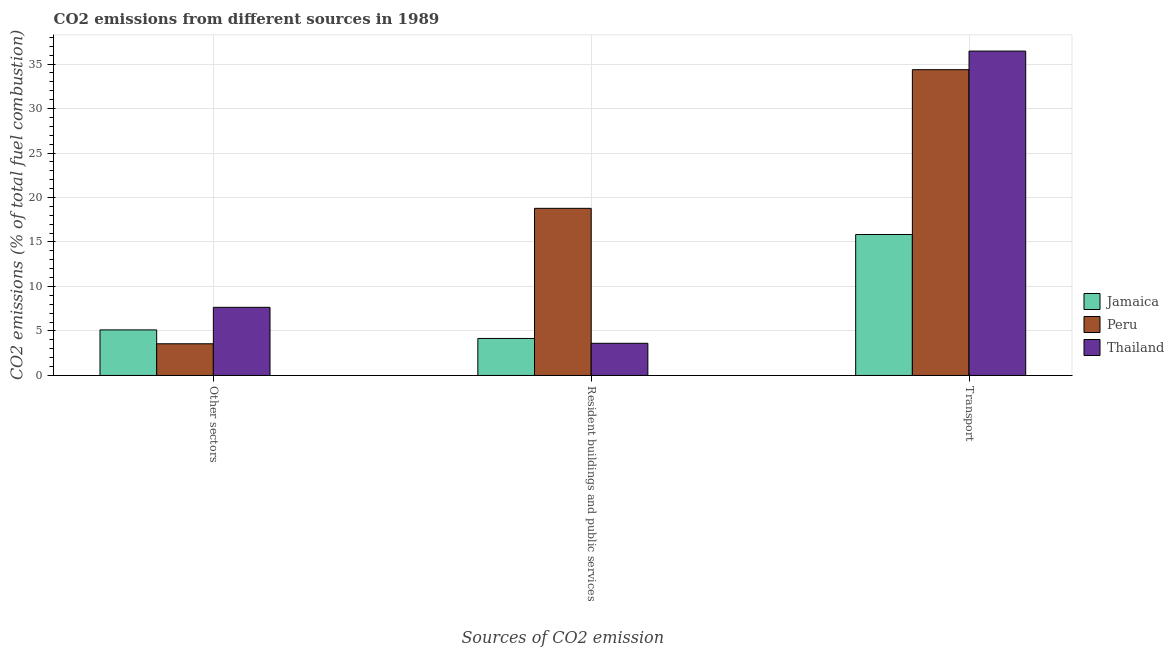How many different coloured bars are there?
Your answer should be compact. 3. How many groups of bars are there?
Offer a very short reply. 3. Are the number of bars per tick equal to the number of legend labels?
Offer a very short reply. Yes. How many bars are there on the 3rd tick from the left?
Make the answer very short. 3. What is the label of the 3rd group of bars from the left?
Keep it short and to the point. Transport. What is the percentage of co2 emissions from other sectors in Jamaica?
Your answer should be compact. 5.12. Across all countries, what is the maximum percentage of co2 emissions from resident buildings and public services?
Your answer should be compact. 18.78. Across all countries, what is the minimum percentage of co2 emissions from other sectors?
Your answer should be very brief. 3.56. In which country was the percentage of co2 emissions from transport maximum?
Your response must be concise. Thailand. In which country was the percentage of co2 emissions from resident buildings and public services minimum?
Your answer should be very brief. Thailand. What is the total percentage of co2 emissions from other sectors in the graph?
Offer a terse response. 16.34. What is the difference between the percentage of co2 emissions from resident buildings and public services in Jamaica and that in Peru?
Offer a very short reply. -14.62. What is the difference between the percentage of co2 emissions from resident buildings and public services in Thailand and the percentage of co2 emissions from other sectors in Peru?
Give a very brief answer. 0.06. What is the average percentage of co2 emissions from resident buildings and public services per country?
Make the answer very short. 8.85. What is the difference between the percentage of co2 emissions from resident buildings and public services and percentage of co2 emissions from transport in Thailand?
Keep it short and to the point. -32.84. In how many countries, is the percentage of co2 emissions from resident buildings and public services greater than 3 %?
Offer a terse response. 3. What is the ratio of the percentage of co2 emissions from transport in Thailand to that in Jamaica?
Offer a terse response. 2.3. Is the percentage of co2 emissions from transport in Peru less than that in Jamaica?
Your response must be concise. No. What is the difference between the highest and the second highest percentage of co2 emissions from transport?
Offer a very short reply. 2.09. What is the difference between the highest and the lowest percentage of co2 emissions from other sectors?
Your answer should be compact. 4.1. What does the 3rd bar from the left in Other sectors represents?
Ensure brevity in your answer.  Thailand. What does the 2nd bar from the right in Resident buildings and public services represents?
Provide a succinct answer. Peru. How many bars are there?
Give a very brief answer. 9. Are all the bars in the graph horizontal?
Make the answer very short. No. What is the difference between two consecutive major ticks on the Y-axis?
Your answer should be very brief. 5. Does the graph contain grids?
Your answer should be compact. Yes. Where does the legend appear in the graph?
Make the answer very short. Center right. How many legend labels are there?
Your answer should be very brief. 3. How are the legend labels stacked?
Your answer should be very brief. Vertical. What is the title of the graph?
Offer a very short reply. CO2 emissions from different sources in 1989. Does "Romania" appear as one of the legend labels in the graph?
Your answer should be very brief. No. What is the label or title of the X-axis?
Keep it short and to the point. Sources of CO2 emission. What is the label or title of the Y-axis?
Your answer should be compact. CO2 emissions (% of total fuel combustion). What is the CO2 emissions (% of total fuel combustion) in Jamaica in Other sectors?
Give a very brief answer. 5.12. What is the CO2 emissions (% of total fuel combustion) in Peru in Other sectors?
Offer a terse response. 3.56. What is the CO2 emissions (% of total fuel combustion) of Thailand in Other sectors?
Provide a short and direct response. 7.66. What is the CO2 emissions (% of total fuel combustion) of Jamaica in Resident buildings and public services?
Keep it short and to the point. 4.16. What is the CO2 emissions (% of total fuel combustion) of Peru in Resident buildings and public services?
Provide a short and direct response. 18.78. What is the CO2 emissions (% of total fuel combustion) in Thailand in Resident buildings and public services?
Offer a very short reply. 3.62. What is the CO2 emissions (% of total fuel combustion) of Jamaica in Transport?
Make the answer very short. 15.84. What is the CO2 emissions (% of total fuel combustion) of Peru in Transport?
Give a very brief answer. 34.37. What is the CO2 emissions (% of total fuel combustion) of Thailand in Transport?
Provide a succinct answer. 36.45. Across all Sources of CO2 emission, what is the maximum CO2 emissions (% of total fuel combustion) in Jamaica?
Your answer should be very brief. 15.84. Across all Sources of CO2 emission, what is the maximum CO2 emissions (% of total fuel combustion) in Peru?
Offer a very short reply. 34.37. Across all Sources of CO2 emission, what is the maximum CO2 emissions (% of total fuel combustion) of Thailand?
Your response must be concise. 36.45. Across all Sources of CO2 emission, what is the minimum CO2 emissions (% of total fuel combustion) of Jamaica?
Offer a very short reply. 4.16. Across all Sources of CO2 emission, what is the minimum CO2 emissions (% of total fuel combustion) in Peru?
Make the answer very short. 3.56. Across all Sources of CO2 emission, what is the minimum CO2 emissions (% of total fuel combustion) of Thailand?
Keep it short and to the point. 3.62. What is the total CO2 emissions (% of total fuel combustion) in Jamaica in the graph?
Offer a very short reply. 25.12. What is the total CO2 emissions (% of total fuel combustion) in Peru in the graph?
Ensure brevity in your answer.  56.71. What is the total CO2 emissions (% of total fuel combustion) of Thailand in the graph?
Your answer should be very brief. 47.73. What is the difference between the CO2 emissions (% of total fuel combustion) of Peru in Other sectors and that in Resident buildings and public services?
Your answer should be compact. -15.22. What is the difference between the CO2 emissions (% of total fuel combustion) in Thailand in Other sectors and that in Resident buildings and public services?
Make the answer very short. 4.04. What is the difference between the CO2 emissions (% of total fuel combustion) in Jamaica in Other sectors and that in Transport?
Make the answer very short. -10.72. What is the difference between the CO2 emissions (% of total fuel combustion) in Peru in Other sectors and that in Transport?
Keep it short and to the point. -30.8. What is the difference between the CO2 emissions (% of total fuel combustion) in Thailand in Other sectors and that in Transport?
Make the answer very short. -28.8. What is the difference between the CO2 emissions (% of total fuel combustion) of Jamaica in Resident buildings and public services and that in Transport?
Make the answer very short. -11.68. What is the difference between the CO2 emissions (% of total fuel combustion) in Peru in Resident buildings and public services and that in Transport?
Provide a succinct answer. -15.58. What is the difference between the CO2 emissions (% of total fuel combustion) of Thailand in Resident buildings and public services and that in Transport?
Give a very brief answer. -32.84. What is the difference between the CO2 emissions (% of total fuel combustion) in Jamaica in Other sectors and the CO2 emissions (% of total fuel combustion) in Peru in Resident buildings and public services?
Provide a succinct answer. -13.66. What is the difference between the CO2 emissions (% of total fuel combustion) of Jamaica in Other sectors and the CO2 emissions (% of total fuel combustion) of Thailand in Resident buildings and public services?
Give a very brief answer. 1.5. What is the difference between the CO2 emissions (% of total fuel combustion) of Peru in Other sectors and the CO2 emissions (% of total fuel combustion) of Thailand in Resident buildings and public services?
Keep it short and to the point. -0.06. What is the difference between the CO2 emissions (% of total fuel combustion) in Jamaica in Other sectors and the CO2 emissions (% of total fuel combustion) in Peru in Transport?
Give a very brief answer. -29.25. What is the difference between the CO2 emissions (% of total fuel combustion) of Jamaica in Other sectors and the CO2 emissions (% of total fuel combustion) of Thailand in Transport?
Keep it short and to the point. -31.33. What is the difference between the CO2 emissions (% of total fuel combustion) of Peru in Other sectors and the CO2 emissions (% of total fuel combustion) of Thailand in Transport?
Provide a short and direct response. -32.89. What is the difference between the CO2 emissions (% of total fuel combustion) of Jamaica in Resident buildings and public services and the CO2 emissions (% of total fuel combustion) of Peru in Transport?
Your answer should be compact. -30.21. What is the difference between the CO2 emissions (% of total fuel combustion) in Jamaica in Resident buildings and public services and the CO2 emissions (% of total fuel combustion) in Thailand in Transport?
Your response must be concise. -32.29. What is the difference between the CO2 emissions (% of total fuel combustion) of Peru in Resident buildings and public services and the CO2 emissions (% of total fuel combustion) of Thailand in Transport?
Your answer should be compact. -17.67. What is the average CO2 emissions (% of total fuel combustion) in Jamaica per Sources of CO2 emission?
Your response must be concise. 8.37. What is the average CO2 emissions (% of total fuel combustion) in Peru per Sources of CO2 emission?
Give a very brief answer. 18.9. What is the average CO2 emissions (% of total fuel combustion) of Thailand per Sources of CO2 emission?
Make the answer very short. 15.91. What is the difference between the CO2 emissions (% of total fuel combustion) of Jamaica and CO2 emissions (% of total fuel combustion) of Peru in Other sectors?
Provide a short and direct response. 1.56. What is the difference between the CO2 emissions (% of total fuel combustion) in Jamaica and CO2 emissions (% of total fuel combustion) in Thailand in Other sectors?
Your answer should be compact. -2.54. What is the difference between the CO2 emissions (% of total fuel combustion) of Peru and CO2 emissions (% of total fuel combustion) of Thailand in Other sectors?
Offer a terse response. -4.1. What is the difference between the CO2 emissions (% of total fuel combustion) in Jamaica and CO2 emissions (% of total fuel combustion) in Peru in Resident buildings and public services?
Provide a short and direct response. -14.62. What is the difference between the CO2 emissions (% of total fuel combustion) in Jamaica and CO2 emissions (% of total fuel combustion) in Thailand in Resident buildings and public services?
Make the answer very short. 0.54. What is the difference between the CO2 emissions (% of total fuel combustion) in Peru and CO2 emissions (% of total fuel combustion) in Thailand in Resident buildings and public services?
Your response must be concise. 15.17. What is the difference between the CO2 emissions (% of total fuel combustion) of Jamaica and CO2 emissions (% of total fuel combustion) of Peru in Transport?
Your answer should be compact. -18.53. What is the difference between the CO2 emissions (% of total fuel combustion) in Jamaica and CO2 emissions (% of total fuel combustion) in Thailand in Transport?
Your answer should be very brief. -20.61. What is the difference between the CO2 emissions (% of total fuel combustion) of Peru and CO2 emissions (% of total fuel combustion) of Thailand in Transport?
Your answer should be very brief. -2.09. What is the ratio of the CO2 emissions (% of total fuel combustion) of Jamaica in Other sectors to that in Resident buildings and public services?
Offer a terse response. 1.23. What is the ratio of the CO2 emissions (% of total fuel combustion) in Peru in Other sectors to that in Resident buildings and public services?
Ensure brevity in your answer.  0.19. What is the ratio of the CO2 emissions (% of total fuel combustion) in Thailand in Other sectors to that in Resident buildings and public services?
Offer a very short reply. 2.12. What is the ratio of the CO2 emissions (% of total fuel combustion) of Jamaica in Other sectors to that in Transport?
Offer a very short reply. 0.32. What is the ratio of the CO2 emissions (% of total fuel combustion) of Peru in Other sectors to that in Transport?
Provide a succinct answer. 0.1. What is the ratio of the CO2 emissions (% of total fuel combustion) in Thailand in Other sectors to that in Transport?
Provide a short and direct response. 0.21. What is the ratio of the CO2 emissions (% of total fuel combustion) in Jamaica in Resident buildings and public services to that in Transport?
Your response must be concise. 0.26. What is the ratio of the CO2 emissions (% of total fuel combustion) in Peru in Resident buildings and public services to that in Transport?
Provide a short and direct response. 0.55. What is the ratio of the CO2 emissions (% of total fuel combustion) in Thailand in Resident buildings and public services to that in Transport?
Give a very brief answer. 0.1. What is the difference between the highest and the second highest CO2 emissions (% of total fuel combustion) of Jamaica?
Your response must be concise. 10.72. What is the difference between the highest and the second highest CO2 emissions (% of total fuel combustion) in Peru?
Offer a terse response. 15.58. What is the difference between the highest and the second highest CO2 emissions (% of total fuel combustion) of Thailand?
Make the answer very short. 28.8. What is the difference between the highest and the lowest CO2 emissions (% of total fuel combustion) in Jamaica?
Provide a short and direct response. 11.68. What is the difference between the highest and the lowest CO2 emissions (% of total fuel combustion) in Peru?
Provide a succinct answer. 30.8. What is the difference between the highest and the lowest CO2 emissions (% of total fuel combustion) of Thailand?
Offer a terse response. 32.84. 